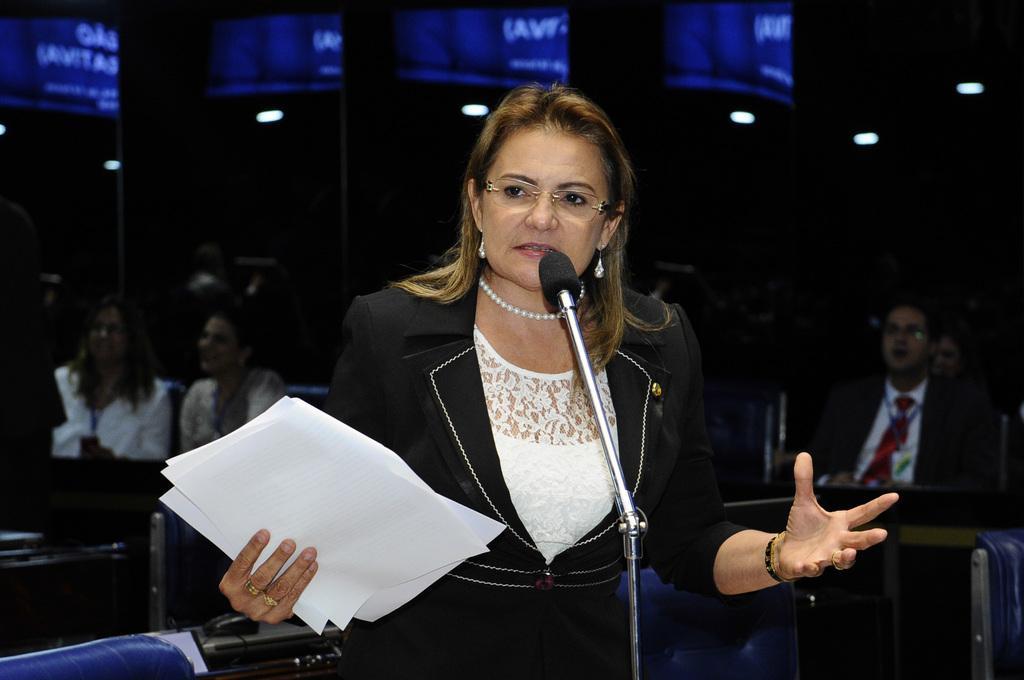How would you summarize this image in a sentence or two? In the center of the image there is a woman standing at mic with papers. In the background there are people sitting on the chairs. 